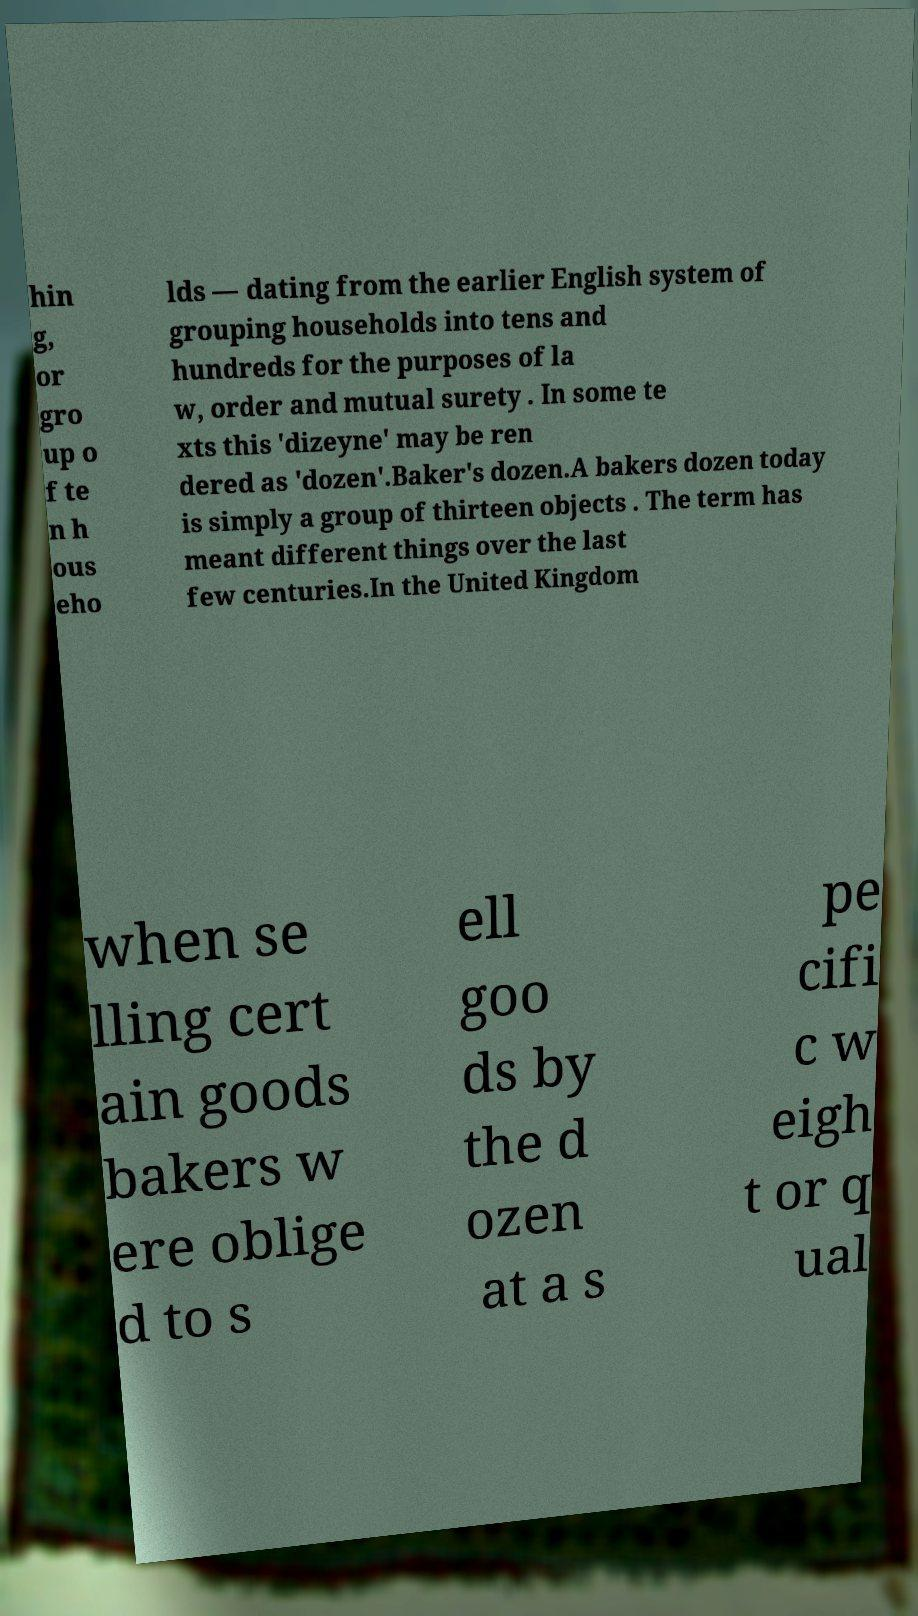There's text embedded in this image that I need extracted. Can you transcribe it verbatim? hin g, or gro up o f te n h ous eho lds — dating from the earlier English system of grouping households into tens and hundreds for the purposes of la w, order and mutual surety . In some te xts this 'dizeyne' may be ren dered as 'dozen'.Baker's dozen.A bakers dozen today is simply a group of thirteen objects . The term has meant different things over the last few centuries.In the United Kingdom when se lling cert ain goods bakers w ere oblige d to s ell goo ds by the d ozen at a s pe cifi c w eigh t or q ual 